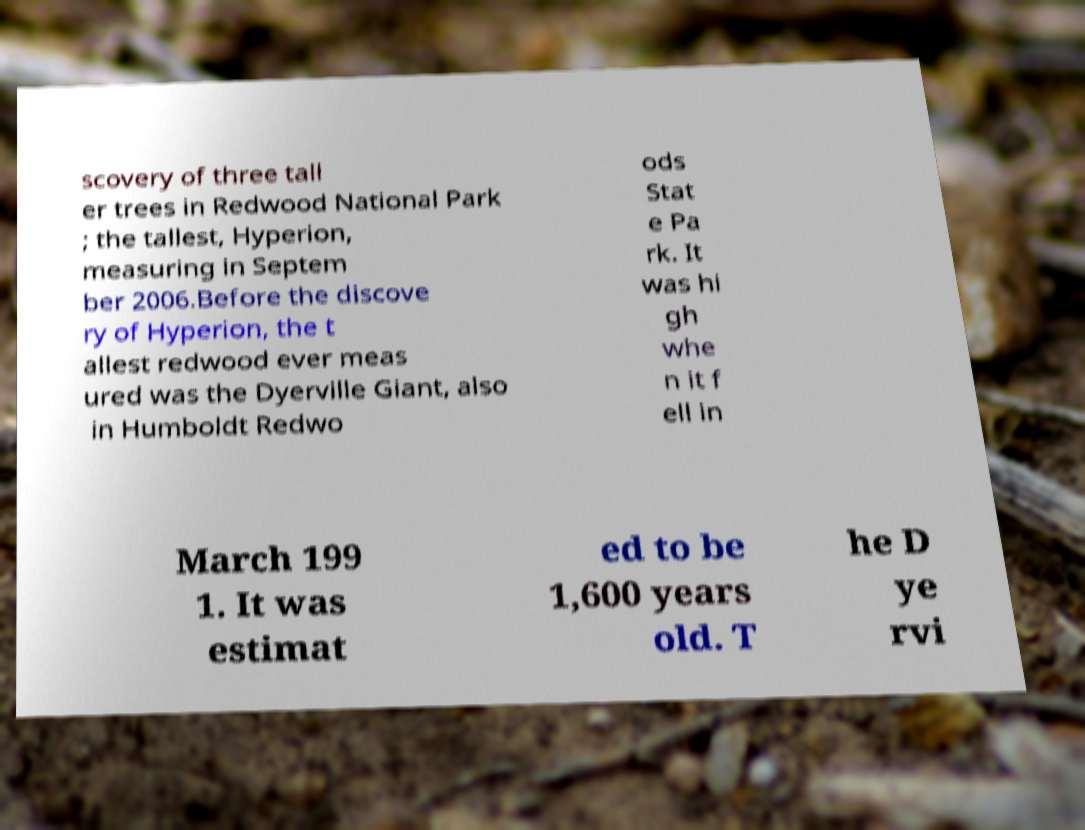Could you extract and type out the text from this image? scovery of three tall er trees in Redwood National Park ; the tallest, Hyperion, measuring in Septem ber 2006.Before the discove ry of Hyperion, the t allest redwood ever meas ured was the Dyerville Giant, also in Humboldt Redwo ods Stat e Pa rk. It was hi gh whe n it f ell in March 199 1. It was estimat ed to be 1,600 years old. T he D ye rvi 